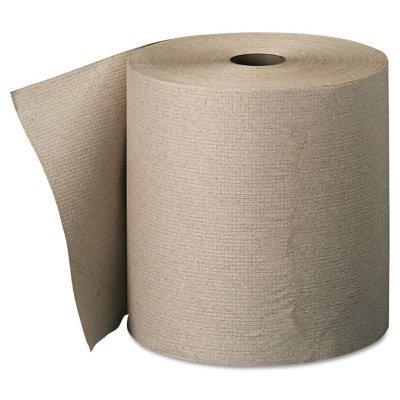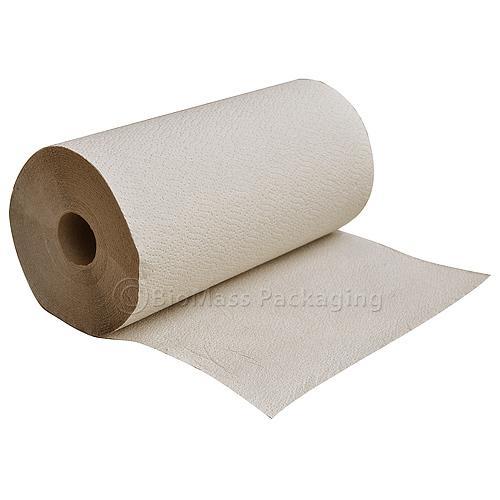The first image is the image on the left, the second image is the image on the right. Examine the images to the left and right. Is the description "There is a folded paper towel on one of the images." accurate? Answer yes or no. No. 